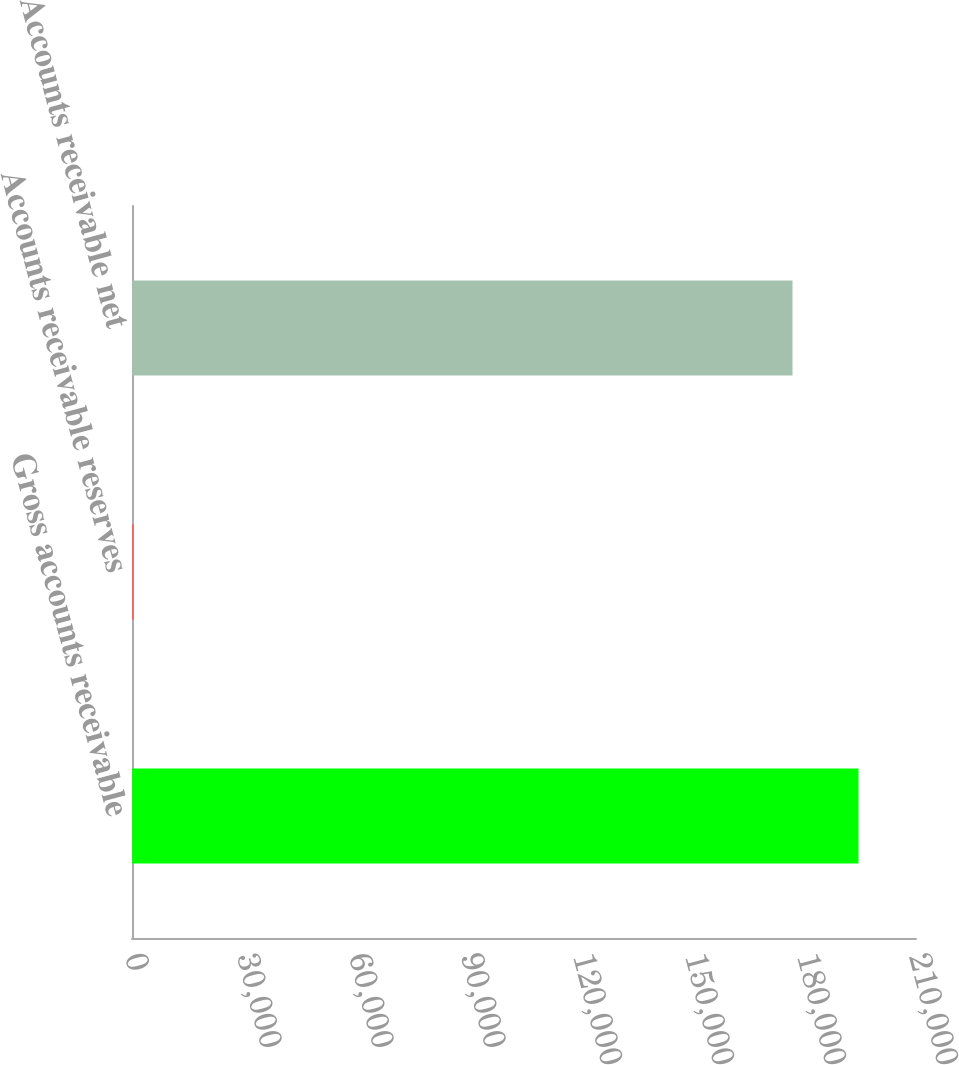Convert chart to OTSL. <chart><loc_0><loc_0><loc_500><loc_500><bar_chart><fcel>Gross accounts receivable<fcel>Accounts receivable reserves<fcel>Accounts receivable net<nl><fcel>194609<fcel>453<fcel>176917<nl></chart> 